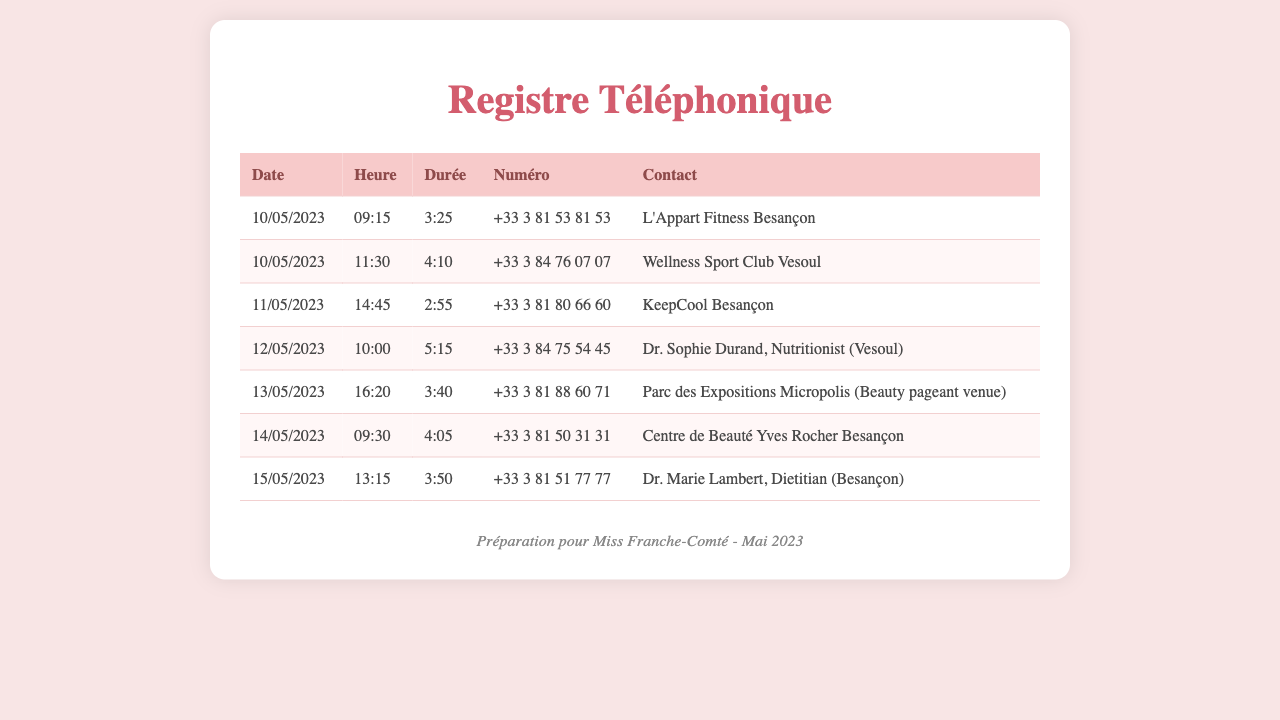What is the date of the first call? The first call in the document was made on 10/05/2023.
Answer: 10/05/2023 Who did you call at 09:15? The call at 09:15 was made to L'Appart Fitness Besançon.
Answer: L'Appart Fitness Besançon What was the duration of the call to Dr. Sophie Durand? The duration of the call to Dr. Sophie Durand was 5:15.
Answer: 5:15 How many calls were made on 10/05/2023? There were two calls made on 10/05/2023, one at 09:15 and another at 11:30.
Answer: 2 Which contact has a longer duration, Dr. Marie Lambert or Dr. Sophie Durand? Dr. Marie Lambert's call lasted 3:50, while Dr. Sophie Durand's lasted 5:15, so Dr. Sophie Durand has a longer duration.
Answer: Dr. Sophie Durand What is the main purpose of these calls? The calls are related to fitness and nutrition, relevant for preparing for Miss Franche-Comté.
Answer: Preparation for Miss Franche-Comté What was the contact for the call made at 16:20 on 13/05/2023? The call at 16:20 on 13/05/2023 was to Parc des Expositions Micropolis.
Answer: Parc des Expositions Micropolis How many different nutritionists were contacted? Two nutritionists were contacted: Dr. Sophie Durand and Dr. Marie Lambert.
Answer: 2 